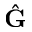Convert formula to latex. <formula><loc_0><loc_0><loc_500><loc_500>\hat { G }</formula> 